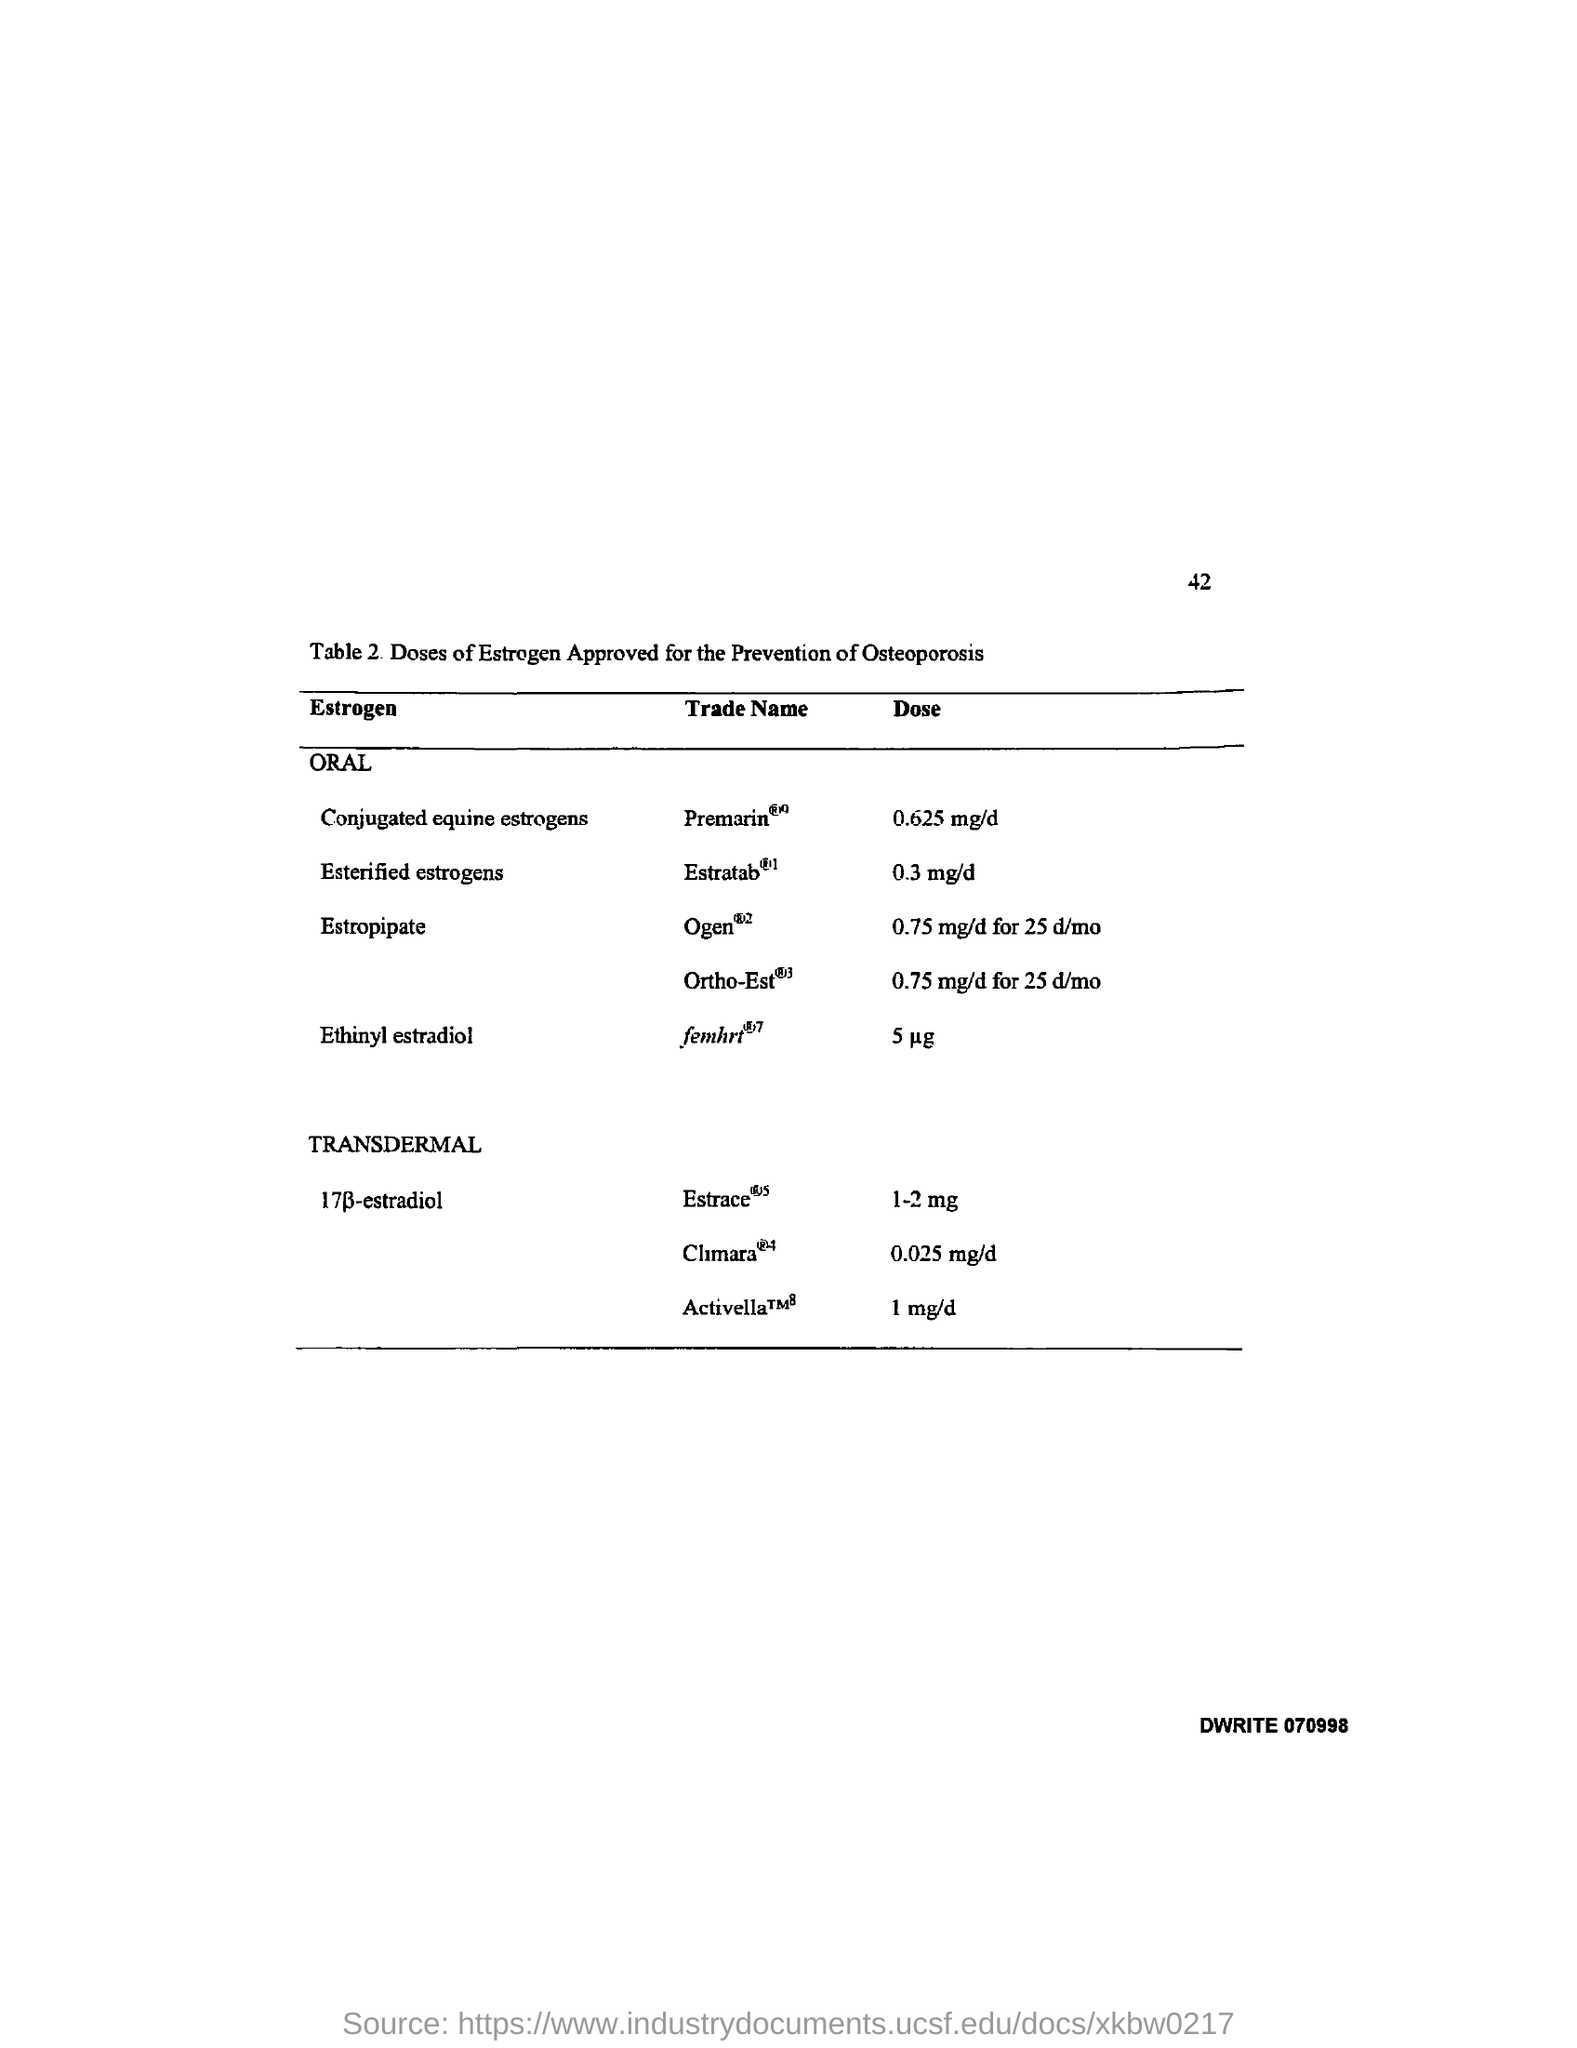Mention a couple of crucial points in this snapshot. The page number is 42. 